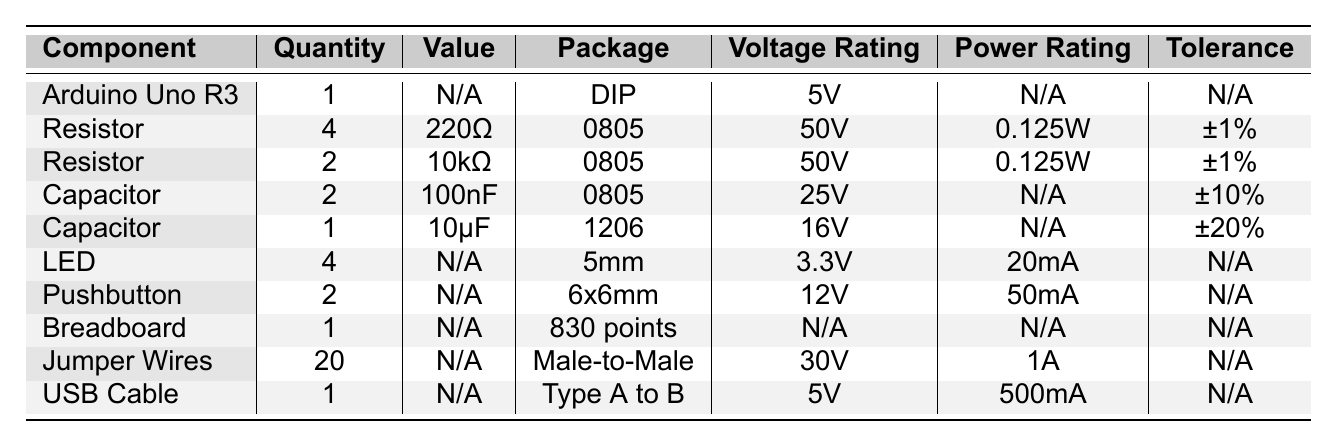What is the voltage rating of the Arduino Uno R3? The table shows a specific entry for the Arduino Uno R3 under the "Voltage Rating" column, which lists it as "5V".
Answer: 5V How many resistors are listed in the table? By counting the entries labeled "Resistor" in the table, there are a total of 6 resistors (4 of 220Ω and 2 of 10kΩ).
Answer: 6 What is the power rating of the capacitors? The table has two types of capacitors, one with a power rating of "N/A" and the other also "N/A", hence both capacitors do not have a specified power rating.
Answer: N/A Is the voltage rating of the jumper wires higher than that of the capacitors? The jumper wires have a voltage rating of "30V", while the capacitors have voltage ratings of "25V" and "16V". Since 30V is greater than both 25V and 16V, the answer is yes.
Answer: Yes What is the total quantity of all components listed in the table? By summing the quantities from each row in the table: 1 (Arduino) + 4 (Resistor 1) + 2 (Resistor 2) + 2 (Capacitor 1) + 1 (Capacitor 2) + 4 (LED) + 2 (Pushbutton) + 1 (Breadboard) + 20 (Jumper Wires) + 1 (USB Cable) = 38.
Answer: 38 What is the tolerance of the resistors? The table shows that both types of resistors (220Ω and 10kΩ) have a tolerance of "±1%", indicating they share this characteristic.
Answer: ±1% How many components have a voltage rating of 5V? Only the Arduino Uno R3 and the USB Cable have a voltage rating of 5V, making it a total of 2 components.
Answer: 2 Are there more capacitors or LEDs in the table? There are 3 capacitors in total (2 of 100nF and 1 of 10µF) and 4 LEDs listed, therefore, there are more LEDs than capacitors.
Answer: More LEDs What is the combined power rating of the resistors? Each resistor has a power rating of 0.125W. Since there are 6 resistors (4 of 220Ω plus 2 of 10kΩ), the combined power rating is 6 × 0.125W = 0.75W.
Answer: 0.75W Is the package type for all resistors the same? Both resistors are listed under the same package type, which is "0805". Therefore, all resistors share the same package type.
Answer: Yes 